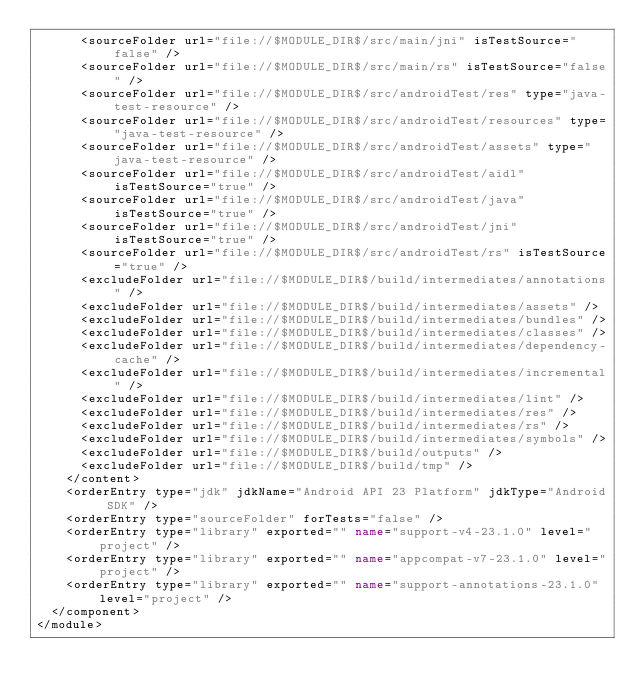Convert code to text. <code><loc_0><loc_0><loc_500><loc_500><_XML_>      <sourceFolder url="file://$MODULE_DIR$/src/main/jni" isTestSource="false" />
      <sourceFolder url="file://$MODULE_DIR$/src/main/rs" isTestSource="false" />
      <sourceFolder url="file://$MODULE_DIR$/src/androidTest/res" type="java-test-resource" />
      <sourceFolder url="file://$MODULE_DIR$/src/androidTest/resources" type="java-test-resource" />
      <sourceFolder url="file://$MODULE_DIR$/src/androidTest/assets" type="java-test-resource" />
      <sourceFolder url="file://$MODULE_DIR$/src/androidTest/aidl" isTestSource="true" />
      <sourceFolder url="file://$MODULE_DIR$/src/androidTest/java" isTestSource="true" />
      <sourceFolder url="file://$MODULE_DIR$/src/androidTest/jni" isTestSource="true" />
      <sourceFolder url="file://$MODULE_DIR$/src/androidTest/rs" isTestSource="true" />
      <excludeFolder url="file://$MODULE_DIR$/build/intermediates/annotations" />
      <excludeFolder url="file://$MODULE_DIR$/build/intermediates/assets" />
      <excludeFolder url="file://$MODULE_DIR$/build/intermediates/bundles" />
      <excludeFolder url="file://$MODULE_DIR$/build/intermediates/classes" />
      <excludeFolder url="file://$MODULE_DIR$/build/intermediates/dependency-cache" />
      <excludeFolder url="file://$MODULE_DIR$/build/intermediates/incremental" />
      <excludeFolder url="file://$MODULE_DIR$/build/intermediates/lint" />
      <excludeFolder url="file://$MODULE_DIR$/build/intermediates/res" />
      <excludeFolder url="file://$MODULE_DIR$/build/intermediates/rs" />
      <excludeFolder url="file://$MODULE_DIR$/build/intermediates/symbols" />
      <excludeFolder url="file://$MODULE_DIR$/build/outputs" />
      <excludeFolder url="file://$MODULE_DIR$/build/tmp" />
    </content>
    <orderEntry type="jdk" jdkName="Android API 23 Platform" jdkType="Android SDK" />
    <orderEntry type="sourceFolder" forTests="false" />
    <orderEntry type="library" exported="" name="support-v4-23.1.0" level="project" />
    <orderEntry type="library" exported="" name="appcompat-v7-23.1.0" level="project" />
    <orderEntry type="library" exported="" name="support-annotations-23.1.0" level="project" />
  </component>
</module></code> 